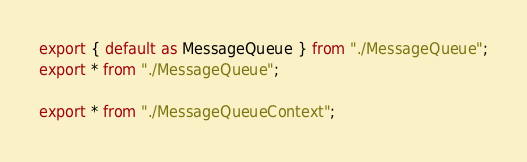<code> <loc_0><loc_0><loc_500><loc_500><_TypeScript_>
export { default as MessageQueue } from "./MessageQueue";
export * from "./MessageQueue";

export * from "./MessageQueueContext";
</code> 